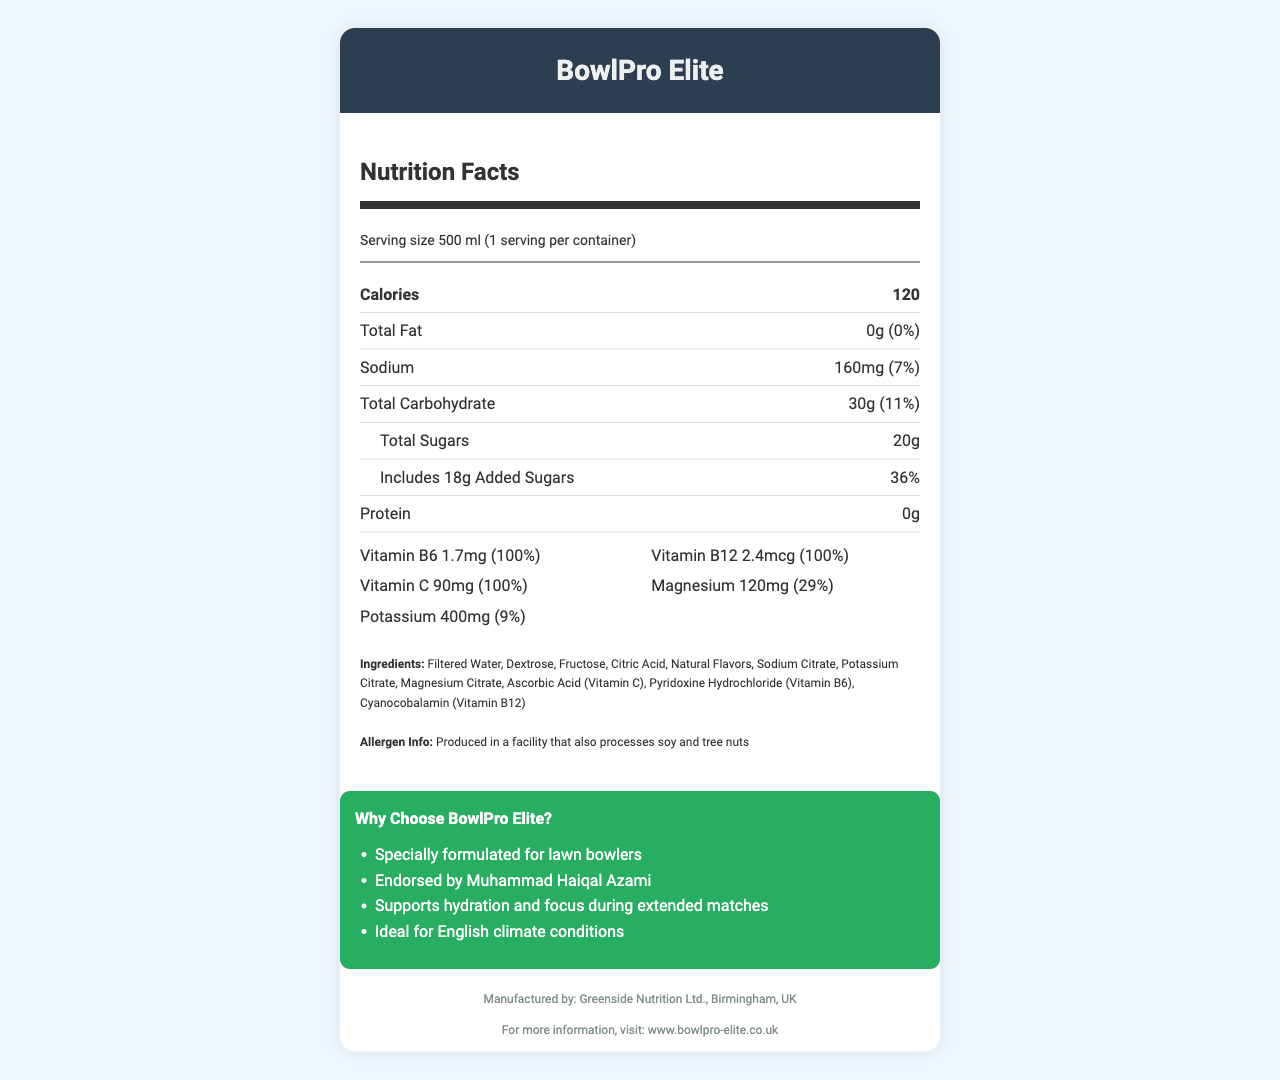what is the serving size for BowlPro Elite? The serving size is listed at the top of the nutrition facts label as 500 ml.
Answer: 500 ml how many calories are in a serving? The number of calories per serving is indicated right after the serving size and is 120.
Answer: 120 how much sodium does BowlPro Elite contain? The sodium content is shown in the nutrient rows and is specified as 160mg.
Answer: 160mg what is the percent daily value of total carbohydrates? The total carbohydrate daily value is listed in the nutrient rows and is 11%.
Answer: 11% how much added sugar is in BowlPro Elite? The amount of added sugars is detailed in the nutrient rows under sugars and is 18g.
Answer: 18g what vitamins and minerals are included in BowlPro Elite? These are listed under the vitamins and minerals section as Vitamin B6 (1.7mg), Vitamin B12 (2.4mcg), Vitamin C (90mg), Magnesium (120mg), and Potassium (400mg).
Answer: Vitamin B6, Vitamin B12, Vitamin C, Magnesium, Potassium which of the following is an ingredient in BowlPro Elite? A. High Fructose Corn Syrup B. Sugar C. Fructose D. Aspartame Fructose is listed in the ingredients section, while the others are not.
Answer: C. Fructose where is BowlPro Elite manufactured? A. London B. Birmingham C. Manchester D. Liverpool The footer of the document states that it is manufactured by Greenside Nutrition Ltd., Birmingham, UK.
Answer: B. Birmingham is BowlPro Elite suitable for someone with tree nut allergies? The allergen info states that it is produced in a facility that also processes soy and tree nuts, which may pose a risk for those with tree nut allergies.
Answer: No summarize the main features of the BowlPro Elite sports drink. The document provides detailed nutritional information, ingredients, allergen information, marketing claims, manufacturer details, and the official website link for more information.
Answer: BowlPro Elite is a vitamin-fortified sports drink specially formulated for lawn bowlers. It has 120 calories per 500 ml serving, with 0g total fat, 160mg sodium, and 30g total carbohydrates, including 20g total sugars with 18g added sugars. It contains beneficial vitamins and minerals such as Vitamin B6, Vitamin B12, Vitamin C, Magnesium, and Potassium. It promises hydration and focus during extended matches, is endorsed by Muhammad Haiqal Azami, and is ideal for the English climate. It is produced by Greenside Nutrition Ltd. in Birmingham, UK. what is the main goal of BowlPro Elite as claimed in the document? This is one of the marketing claims listed in the marketing section of the document.
Answer: Supports hydration and focus during extended matches what is the website for more information about BowlPro Elite? The footer of the document lists the website as www.bowlpro-elite.co.uk.
Answer: www.bowlpro-elite.co.uk how much potassium does BowlPro Elite contain? The amount of potassium is stated in the vitamins and minerals section and is 400mg.
Answer: 400mg what is the daily value percentage for magnesium? The daily value percentage for magnesium is listed as 29% in the vitamins and minerals section.
Answer: 29% is BowlPro Elite endorsed by a famous figure? The marketing section mentions that BowlPro Elite is endorsed by Muhammad Haiqal Azami.
Answer: Yes what is the production facility's other food processing activity? The allergen info mentions that the production facility also processes soy and tree nuts.
Answer: Processes soy and tree nuts how much protein is in BowlPro Elite? The protein content is specified in the nutrient rows and is 0g.
Answer: 0g what is the recommended market for BowlPro Elite as per the product claims? The marketing section states it is specially formulated for lawn bowlers.
Answer: Lawn bowlers does BowlPro Elite include artificial flavors? The ingredients list mentions "Natural Flavors," not artificial ones.
Answer: No does the nutrition facts label appear visually appealing and trustworthy? This question cannot be answered based on the visual information in the document alone since visual appeal and trustworthiness are subjective matters not fully covered by the provided data.
Answer: Cannot be determined 